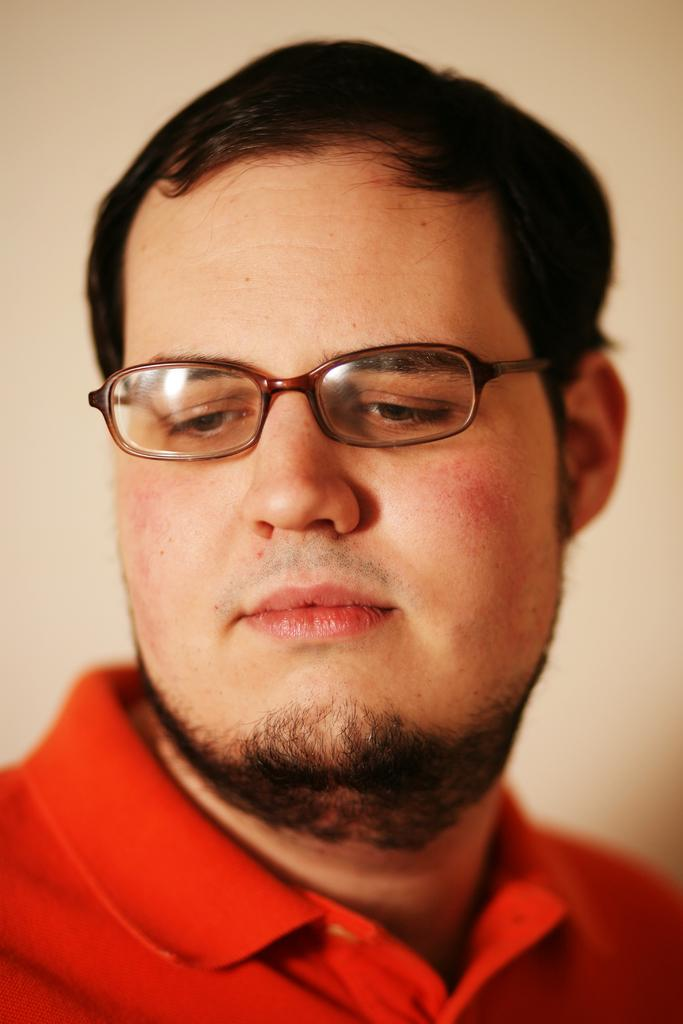Who or what is the main subject in the image? There is a person in the image. What is the person wearing on their upper body? The person is wearing a red t-shirt. Are there any accessories visible on the person? Yes, the person is wearing glasses. What is the color of the background in the image? The background of the image is white. Can you see any icicles hanging from the person's glasses in the image? There are no icicles present in the image, and they are not hanging from the person's glasses. 